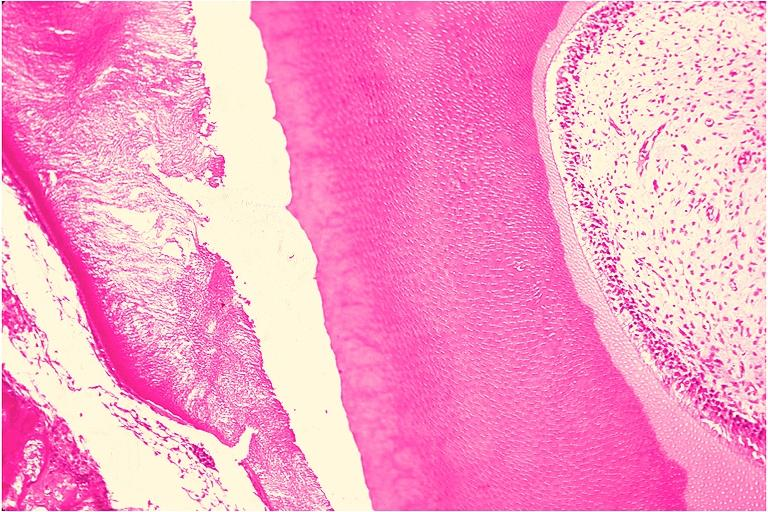s newborn cord around neck present?
Answer the question using a single word or phrase. No 